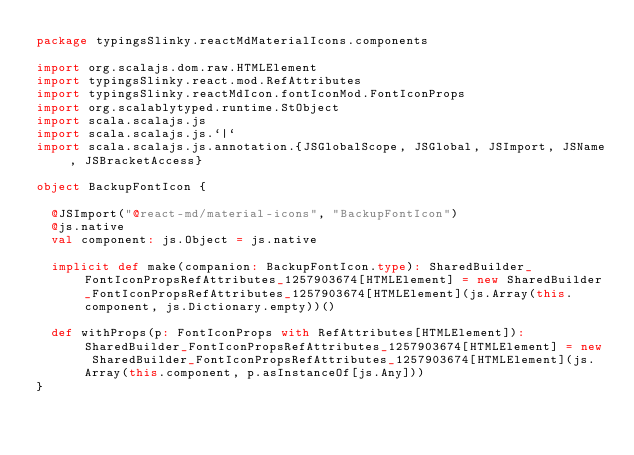<code> <loc_0><loc_0><loc_500><loc_500><_Scala_>package typingsSlinky.reactMdMaterialIcons.components

import org.scalajs.dom.raw.HTMLElement
import typingsSlinky.react.mod.RefAttributes
import typingsSlinky.reactMdIcon.fontIconMod.FontIconProps
import org.scalablytyped.runtime.StObject
import scala.scalajs.js
import scala.scalajs.js.`|`
import scala.scalajs.js.annotation.{JSGlobalScope, JSGlobal, JSImport, JSName, JSBracketAccess}

object BackupFontIcon {
  
  @JSImport("@react-md/material-icons", "BackupFontIcon")
  @js.native
  val component: js.Object = js.native
  
  implicit def make(companion: BackupFontIcon.type): SharedBuilder_FontIconPropsRefAttributes_1257903674[HTMLElement] = new SharedBuilder_FontIconPropsRefAttributes_1257903674[HTMLElement](js.Array(this.component, js.Dictionary.empty))()
  
  def withProps(p: FontIconProps with RefAttributes[HTMLElement]): SharedBuilder_FontIconPropsRefAttributes_1257903674[HTMLElement] = new SharedBuilder_FontIconPropsRefAttributes_1257903674[HTMLElement](js.Array(this.component, p.asInstanceOf[js.Any]))
}
</code> 